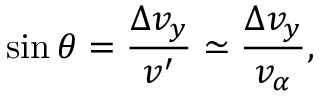Convert formula to latex. <formula><loc_0><loc_0><loc_500><loc_500>\sin \theta = \frac { \Delta v _ { y } } { v ^ { \prime } } \simeq \frac { \Delta v _ { y } } { v _ { \alpha } } ,</formula> 